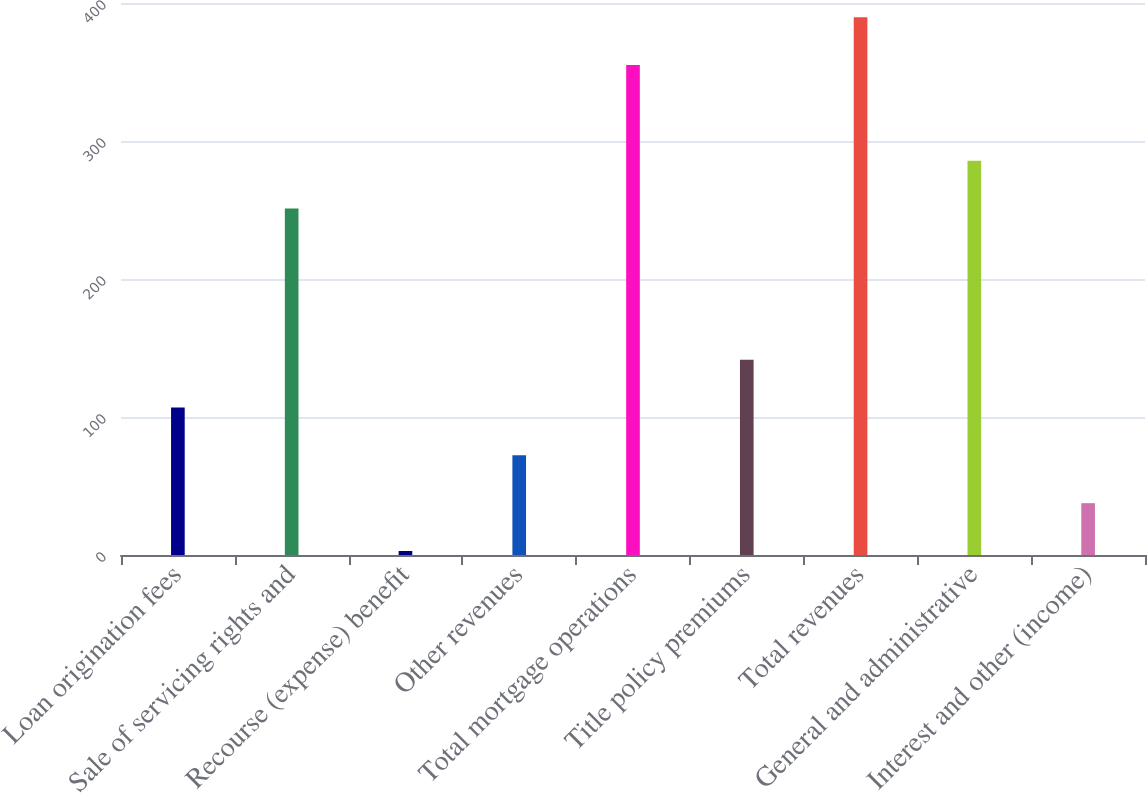<chart> <loc_0><loc_0><loc_500><loc_500><bar_chart><fcel>Loan origination fees<fcel>Sale of servicing rights and<fcel>Recourse (expense) benefit<fcel>Other revenues<fcel>Total mortgage operations<fcel>Title policy premiums<fcel>Total revenues<fcel>General and administrative<fcel>Interest and other (income)<nl><fcel>106.88<fcel>251.1<fcel>2.9<fcel>72.22<fcel>355.08<fcel>141.54<fcel>389.74<fcel>285.76<fcel>37.56<nl></chart> 